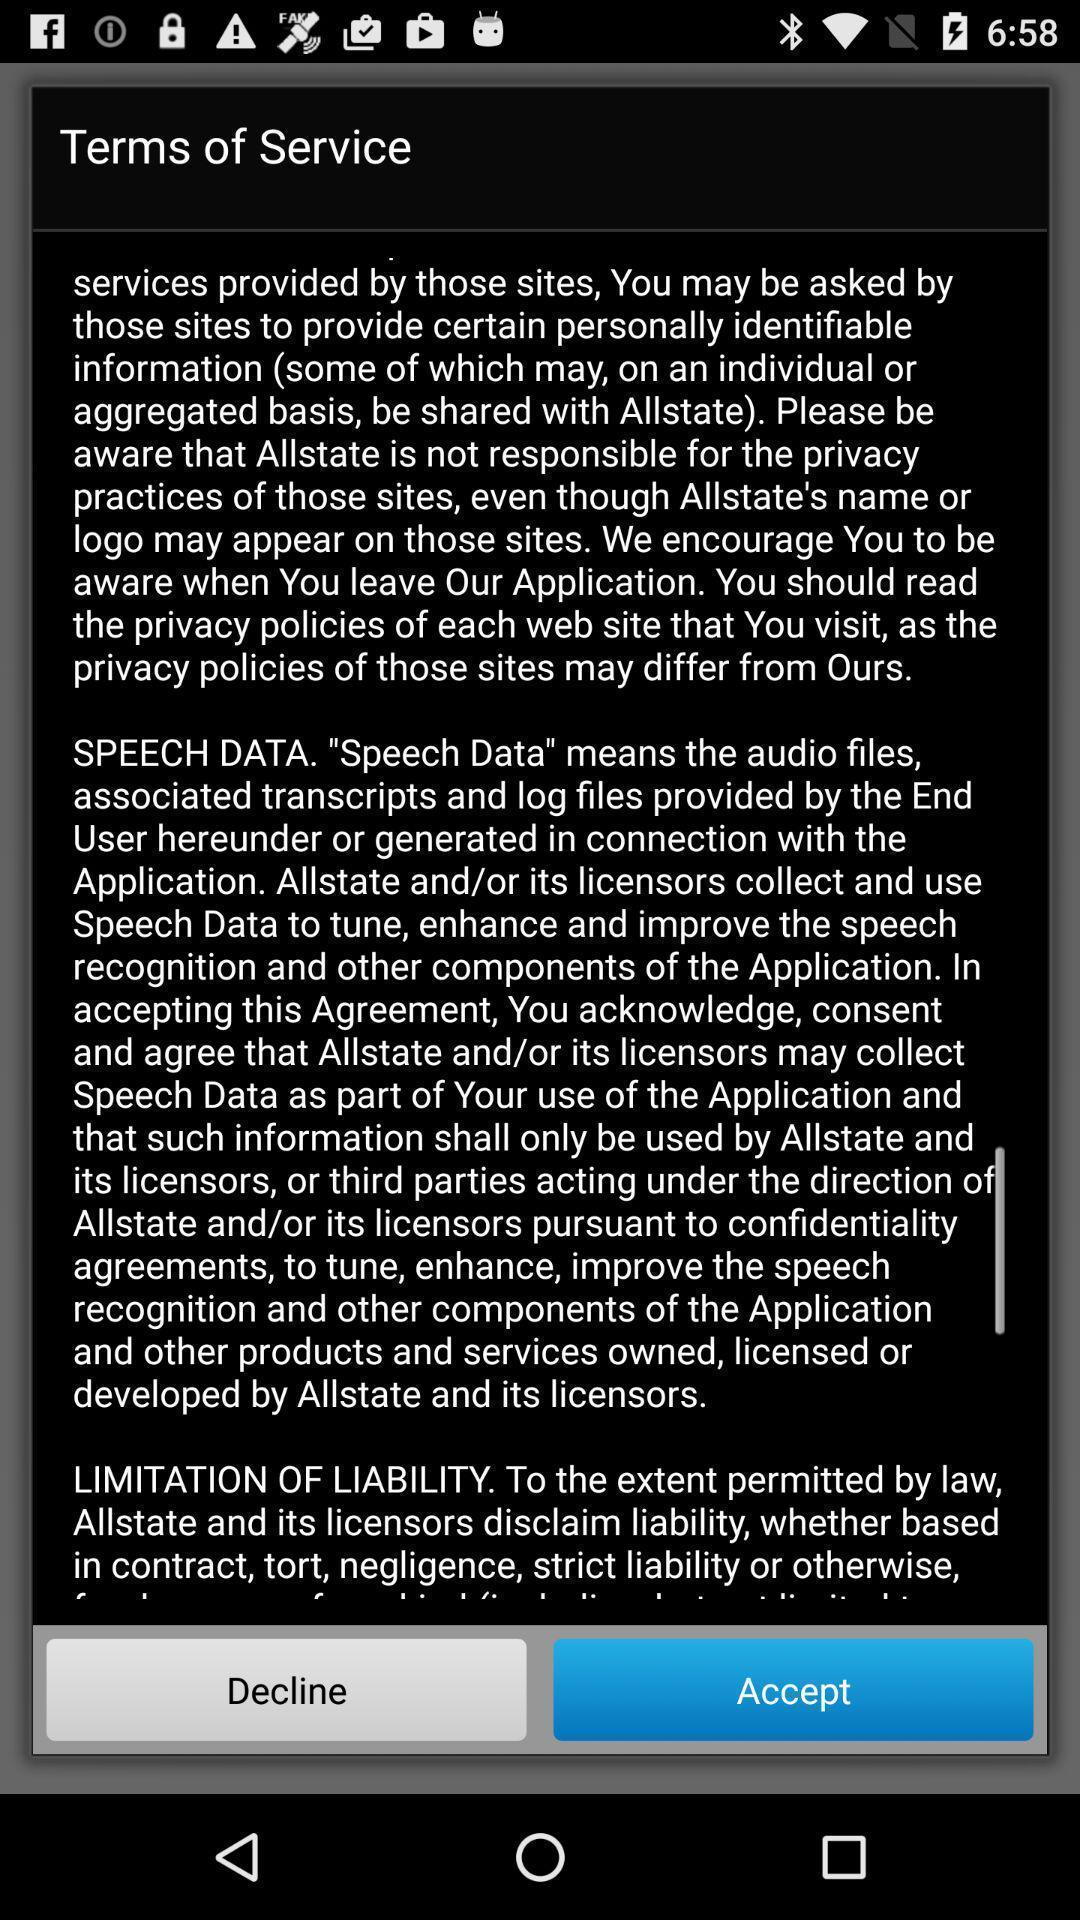What is the overall content of this screenshot? Pop-up displaying with agreement page of the application. 